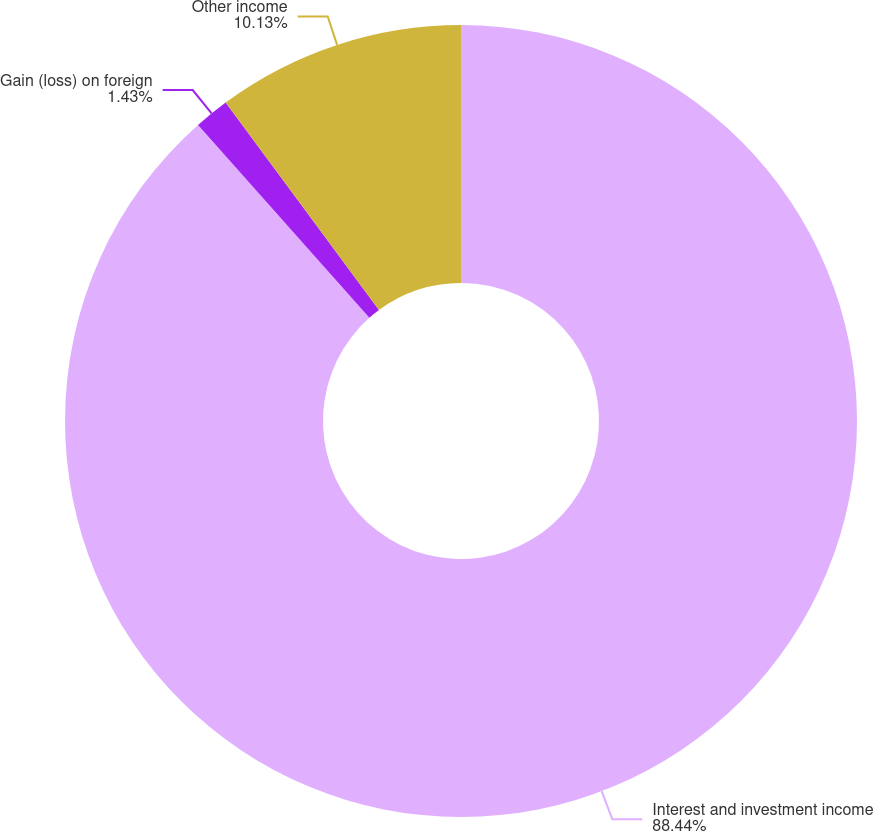Convert chart to OTSL. <chart><loc_0><loc_0><loc_500><loc_500><pie_chart><fcel>Interest and investment income<fcel>Gain (loss) on foreign<fcel>Other income<nl><fcel>88.45%<fcel>1.43%<fcel>10.13%<nl></chart> 